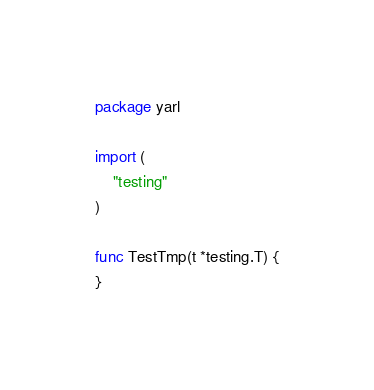Convert code to text. <code><loc_0><loc_0><loc_500><loc_500><_Go_>package yarl

import (
	"testing"
)

func TestTmp(t *testing.T) {
}
</code> 